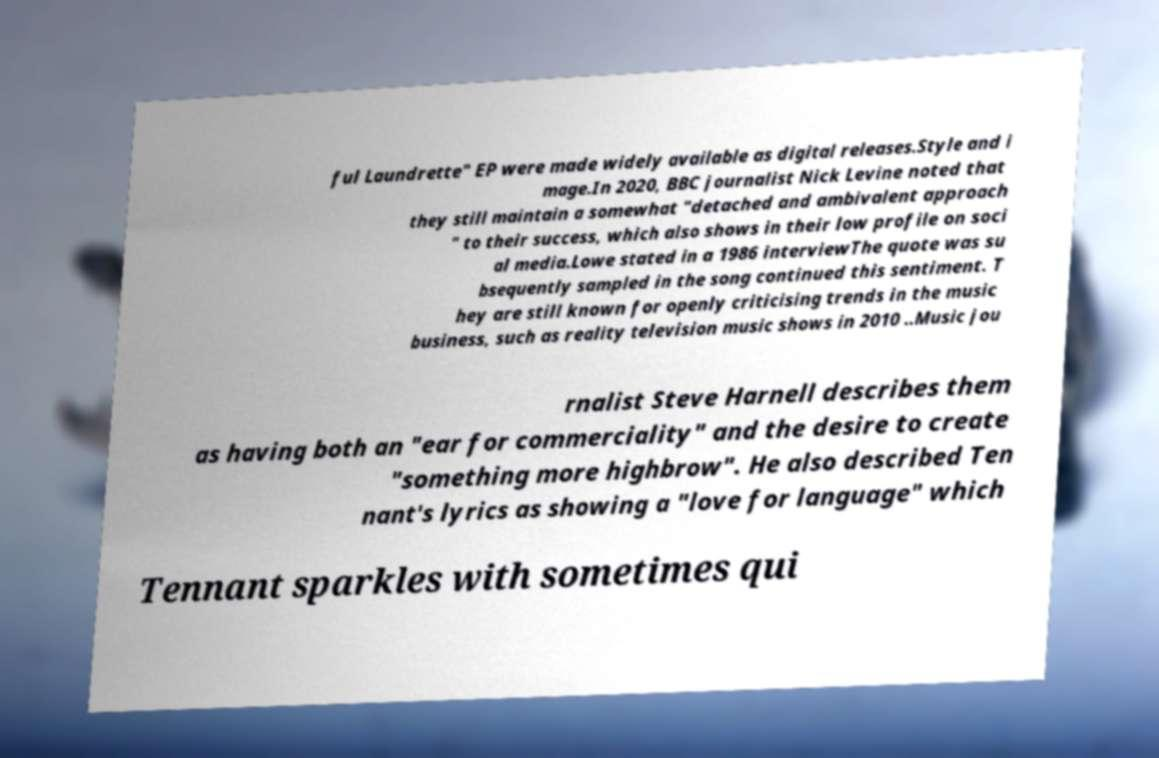I need the written content from this picture converted into text. Can you do that? ful Laundrette" EP were made widely available as digital releases.Style and i mage.In 2020, BBC journalist Nick Levine noted that they still maintain a somewhat "detached and ambivalent approach " to their success, which also shows in their low profile on soci al media.Lowe stated in a 1986 interviewThe quote was su bsequently sampled in the song continued this sentiment. T hey are still known for openly criticising trends in the music business, such as reality television music shows in 2010 ..Music jou rnalist Steve Harnell describes them as having both an "ear for commerciality" and the desire to create "something more highbrow". He also described Ten nant's lyrics as showing a "love for language" which Tennant sparkles with sometimes qui 